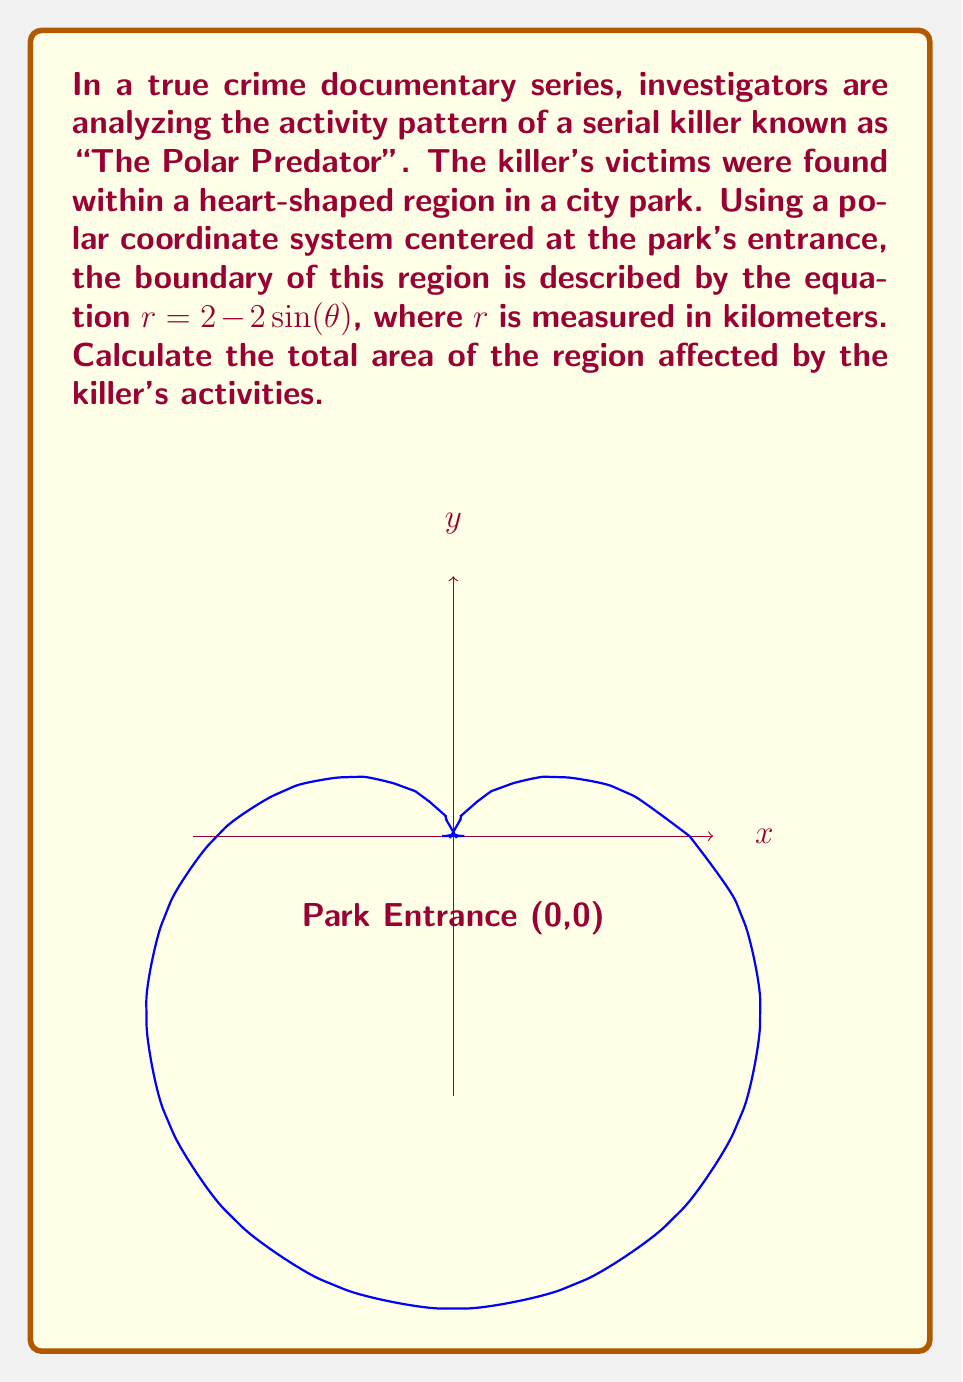What is the answer to this math problem? To solve this problem, we need to use polar integration to calculate the area enclosed by the given curve. Let's break it down step-by-step:

1) The formula for the area of a region in polar coordinates is:

   $$A = \frac{1}{2} \int_{0}^{2\pi} r^2(\theta) d\theta$$

2) In this case, $r(\theta) = 2 - 2\sin(\theta)$

3) We need to square this function:

   $$r^2(\theta) = (2 - 2\sin(\theta))^2 = 4 - 8\sin(\theta) + 4\sin^2(\theta)$$

4) Now, let's set up the integral:

   $$A = \frac{1}{2} \int_{0}^{2\pi} (4 - 8\sin(\theta) + 4\sin^2(\theta)) d\theta$$

5) Let's integrate each term separately:

   $$\frac{1}{2} \int_{0}^{2\pi} 4 d\theta = 2\theta \big|_{0}^{2\pi} = 4\pi$$

   $$\frac{1}{2} \int_{0}^{2\pi} -8\sin(\theta) d\theta = 4\cos(\theta) \big|_{0}^{2\pi} = 0$$

   $$\frac{1}{2} \int_{0}^{2\pi} 4\sin^2(\theta) d\theta = \int_{0}^{2\pi} 2\sin^2(\theta) d\theta = \int_{0}^{2\pi} (1 - \cos(2\theta)) d\theta = \theta - \frac{1}{2}\sin(2\theta) \big|_{0}^{2\pi} = 2\pi$$

6) Adding these results:

   $$A = 4\pi + 0 + 2\pi = 6\pi$$

Therefore, the total area affected by the serial killer's activities is $6\pi$ square kilometers.
Answer: $6\pi$ km² 